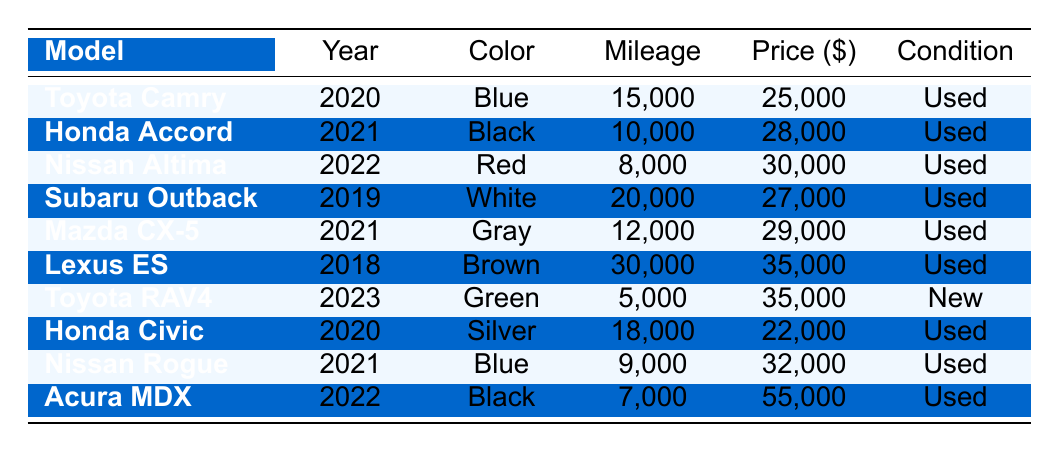What is the price of the 2022 Nissan Altima? The table lists the 2022 Nissan Altima with a price of $30,000.
Answer: $30,000 How many miles does the 2021 Honda Accord have? The table shows that the 2021 Honda Accord has a mileage of 10,000 miles.
Answer: 10,000 Which car has the highest price, and what is it? By reviewing the prices in the table, the 2022 Acura MDX at $55,000 is the highest priced car.
Answer: $55,000 What is the average price of cars from the year 2021? The prices of the 2021 models are $28,000 (Honda Accord), $29,000 (Mazda CX-5), $32,000 (Nissan Rogue). The sum is $28,000 + $29,000 + $32,000 = $89,000. There are 3 cars, thus the average price is $89,000 / 3 = $29,666.67.
Answer: $29,666.67 Are there any new cars in the inventory? The table indicates that the 2023 Toyota RAV4 is listed as "New," confirming the presence of new cars.
Answer: Yes What is the total mileage of all the vehicles from the year 2020? The 2020 cars listed are Toyota Camry (15,000 miles) and Honda Civic (18,000 miles). Adding these gives 15,000 + 18,000 = 33,000 miles total.
Answer: 33,000 miles Which model has the least mileage and what is it? By scanning the mileage data, the 2023 Toyota RAV4 has the least mileage at 5,000 miles among all the models.
Answer: 5,000 miles How does the price of the 2021 Mazda CX-5 compare to that of the 2022 Nissan Altima? The 2021 Mazda CX-5 is priced at $29,000, while the 2022 Nissan Altima is $30,000. Therefore, the Mazda CX-5 is cheaper by $1,000.
Answer: $1,000 cheaper What percentage of the cars in the inventory are "Used"? There are 8 used cars and 1 new car, leading to a total of 9 cars. The percentage of used cars is (8 / 9) * 100 = 88.89%.
Answer: 88.89% Which color options are available for the 2021 Nissan Rogue? The table states that the 2021 Nissan Rogue is available in Blue.
Answer: Blue 